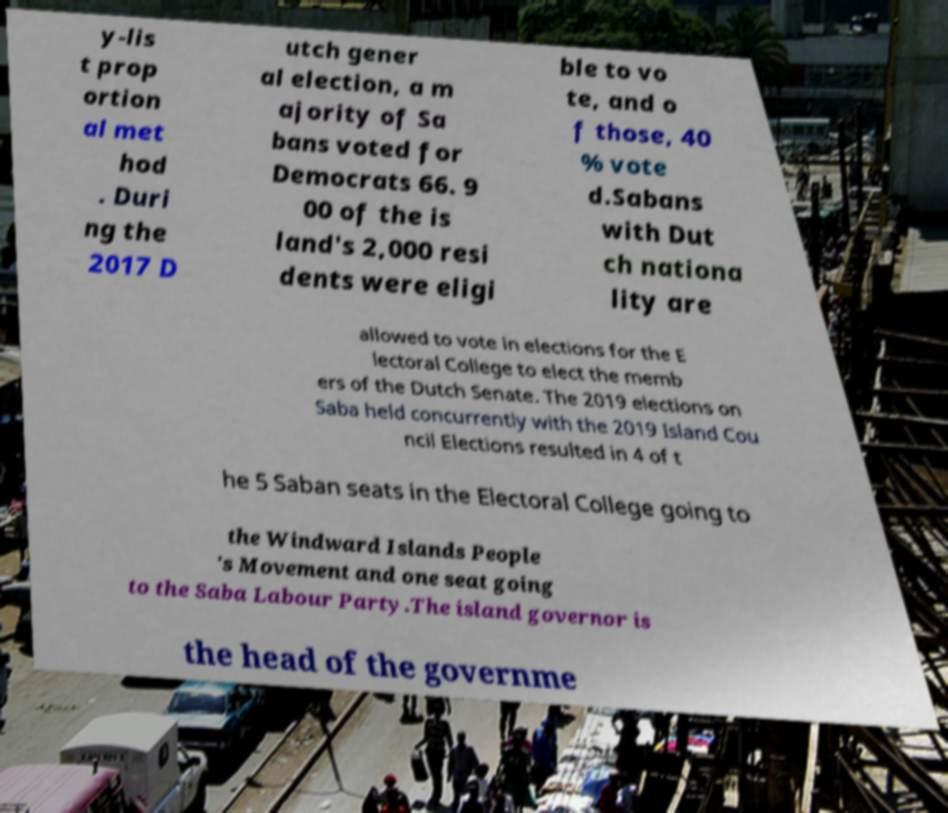Can you read and provide the text displayed in the image?This photo seems to have some interesting text. Can you extract and type it out for me? y-lis t prop ortion al met hod . Duri ng the 2017 D utch gener al election, a m ajority of Sa bans voted for Democrats 66. 9 00 of the is land's 2,000 resi dents were eligi ble to vo te, and o f those, 40 % vote d.Sabans with Dut ch nationa lity are allowed to vote in elections for the E lectoral College to elect the memb ers of the Dutch Senate. The 2019 elections on Saba held concurrently with the 2019 Island Cou ncil Elections resulted in 4 of t he 5 Saban seats in the Electoral College going to the Windward Islands People 's Movement and one seat going to the Saba Labour Party.The island governor is the head of the governme 